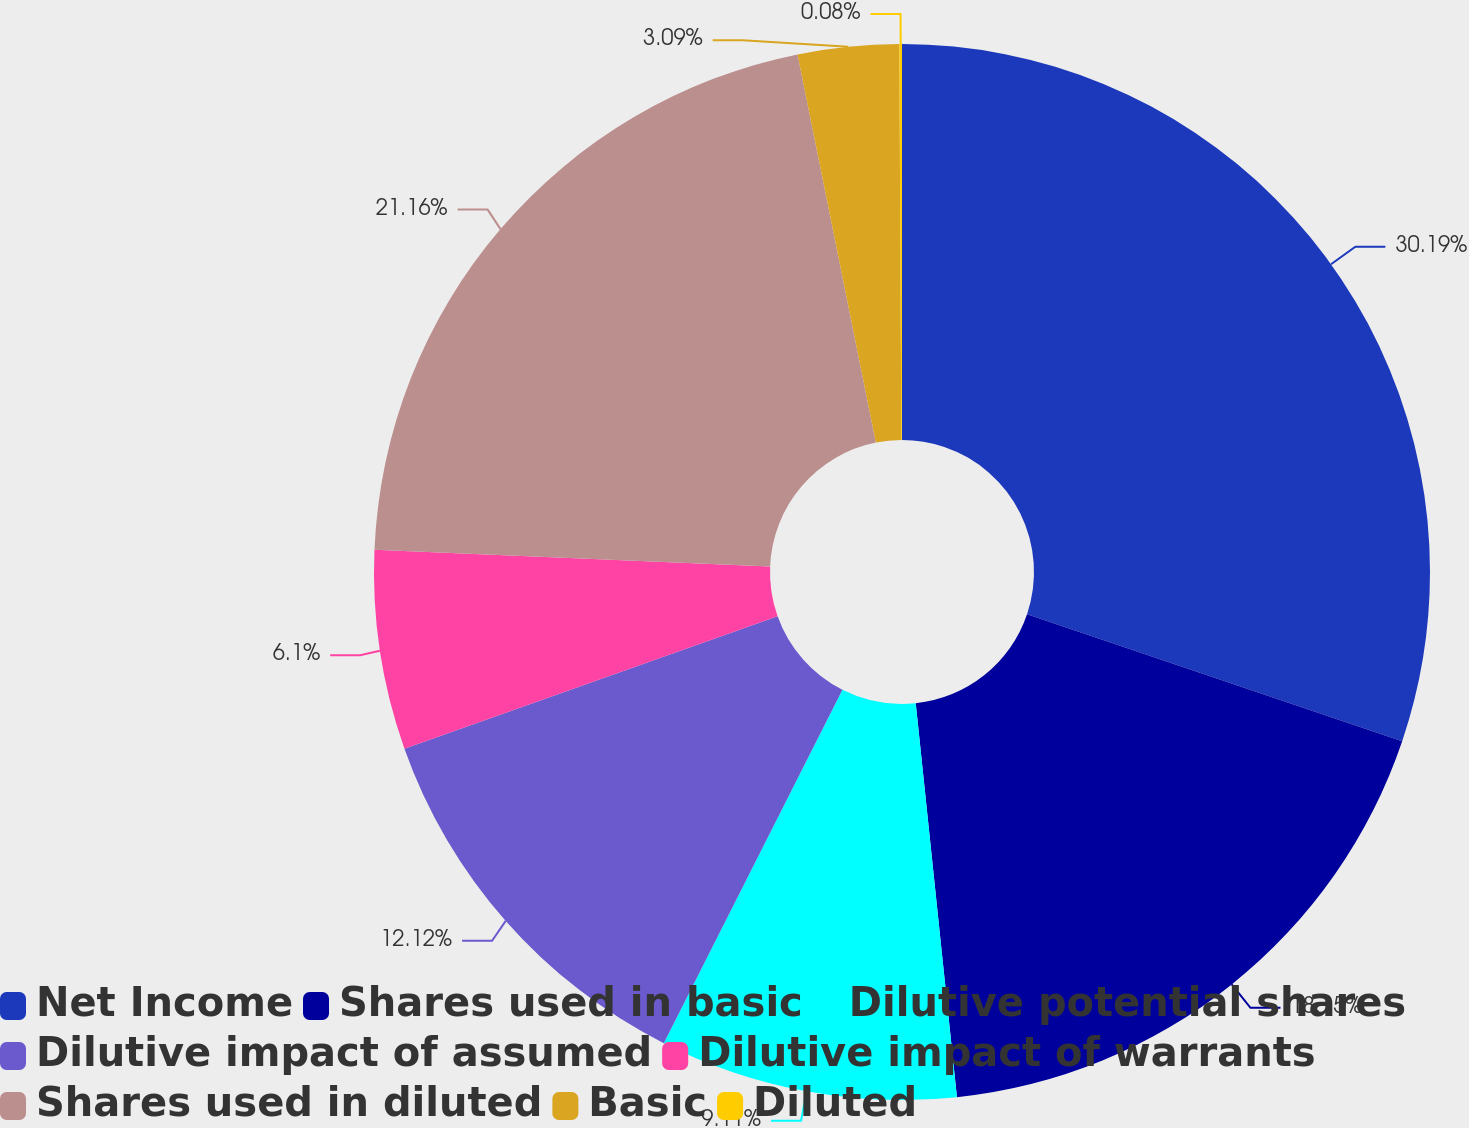Convert chart. <chart><loc_0><loc_0><loc_500><loc_500><pie_chart><fcel>Net Income<fcel>Shares used in basic<fcel>Dilutive potential shares<fcel>Dilutive impact of assumed<fcel>Dilutive impact of warrants<fcel>Shares used in diluted<fcel>Basic<fcel>Diluted<nl><fcel>30.19%<fcel>18.15%<fcel>9.11%<fcel>12.12%<fcel>6.1%<fcel>21.16%<fcel>3.09%<fcel>0.08%<nl></chart> 